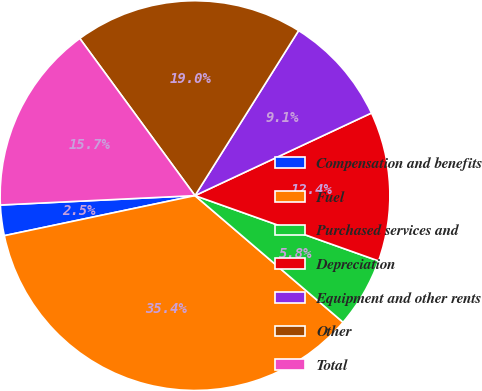Convert chart to OTSL. <chart><loc_0><loc_0><loc_500><loc_500><pie_chart><fcel>Compensation and benefits<fcel>Fuel<fcel>Purchased services and<fcel>Depreciation<fcel>Equipment and other rents<fcel>Other<fcel>Total<nl><fcel>2.53%<fcel>35.44%<fcel>5.82%<fcel>12.41%<fcel>9.11%<fcel>18.99%<fcel>15.7%<nl></chart> 